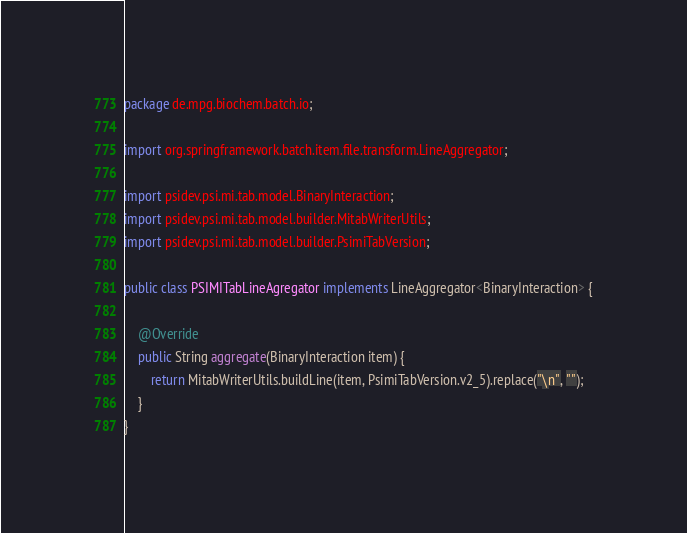Convert code to text. <code><loc_0><loc_0><loc_500><loc_500><_Java_>package de.mpg.biochem.batch.io;

import org.springframework.batch.item.file.transform.LineAggregator;

import psidev.psi.mi.tab.model.BinaryInteraction;
import psidev.psi.mi.tab.model.builder.MitabWriterUtils;
import psidev.psi.mi.tab.model.builder.PsimiTabVersion;

public class PSIMITabLineAgregator implements LineAggregator<BinaryInteraction> {

	@Override
	public String aggregate(BinaryInteraction item) {
		return MitabWriterUtils.buildLine(item, PsimiTabVersion.v2_5).replace("\n", "");
	}
}
</code> 